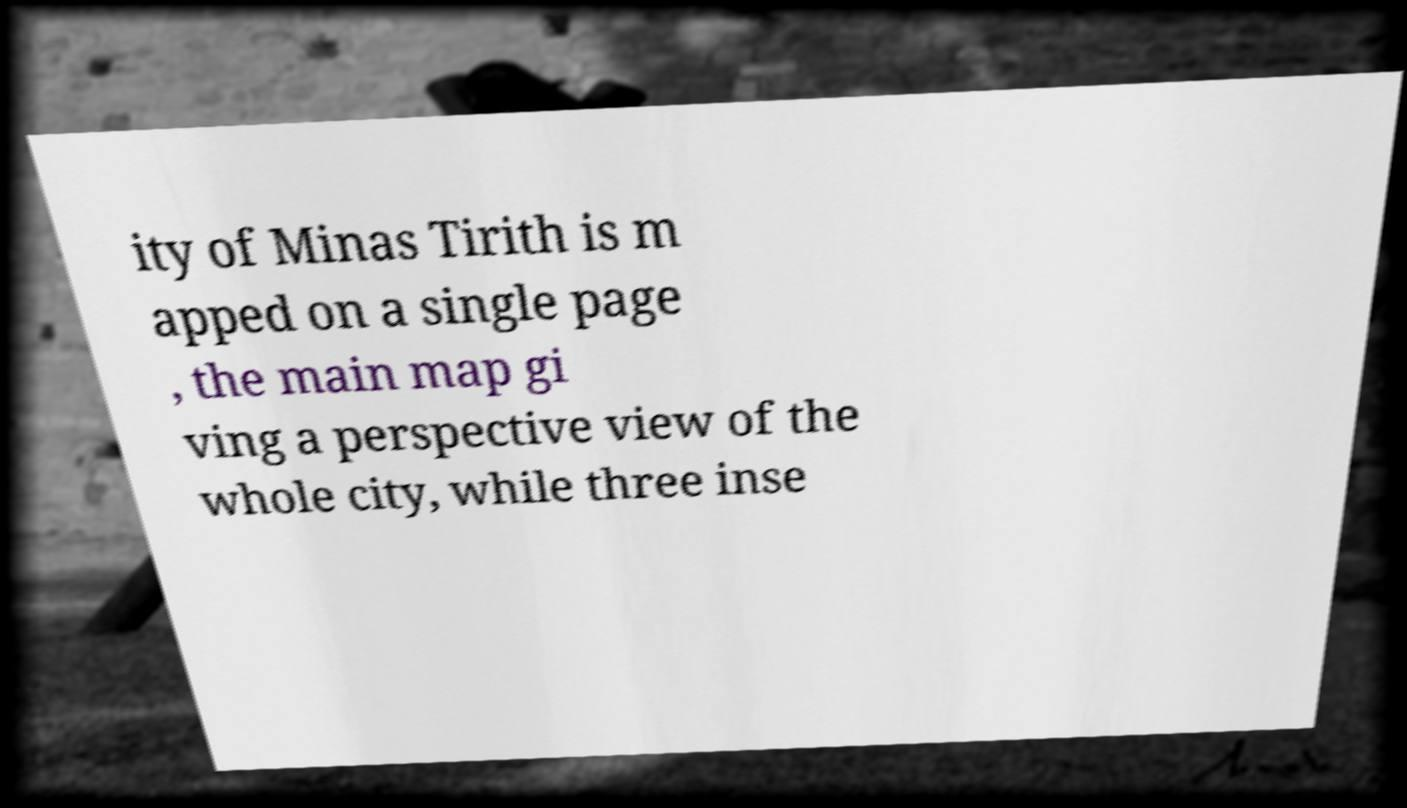Please read and relay the text visible in this image. What does it say? ity of Minas Tirith is m apped on a single page , the main map gi ving a perspective view of the whole city, while three inse 